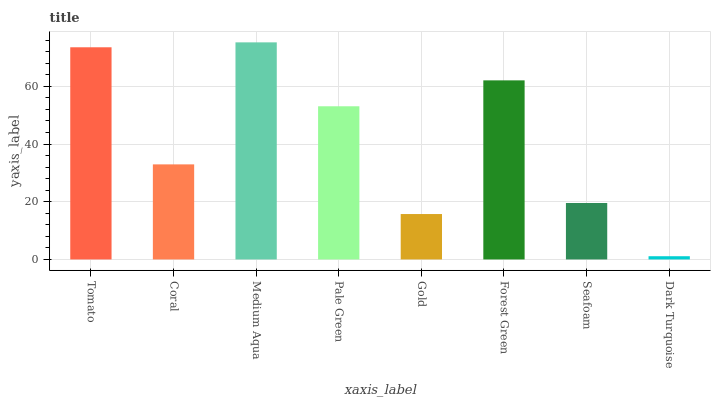Is Dark Turquoise the minimum?
Answer yes or no. Yes. Is Medium Aqua the maximum?
Answer yes or no. Yes. Is Coral the minimum?
Answer yes or no. No. Is Coral the maximum?
Answer yes or no. No. Is Tomato greater than Coral?
Answer yes or no. Yes. Is Coral less than Tomato?
Answer yes or no. Yes. Is Coral greater than Tomato?
Answer yes or no. No. Is Tomato less than Coral?
Answer yes or no. No. Is Pale Green the high median?
Answer yes or no. Yes. Is Coral the low median?
Answer yes or no. Yes. Is Gold the high median?
Answer yes or no. No. Is Tomato the low median?
Answer yes or no. No. 